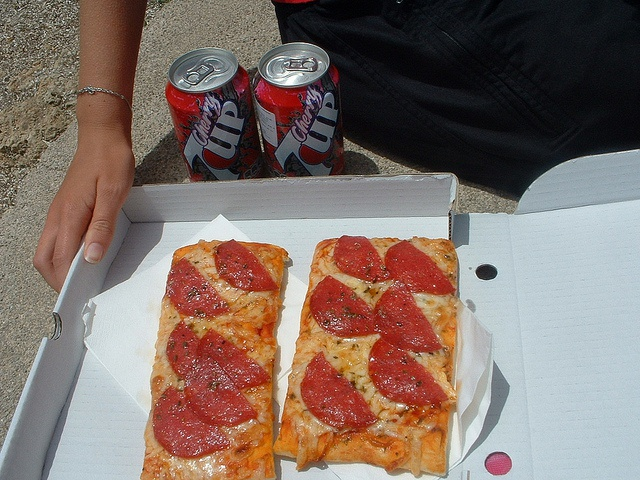Describe the objects in this image and their specific colors. I can see pizza in gray, brown, and tan tones and people in gray, brown, and maroon tones in this image. 